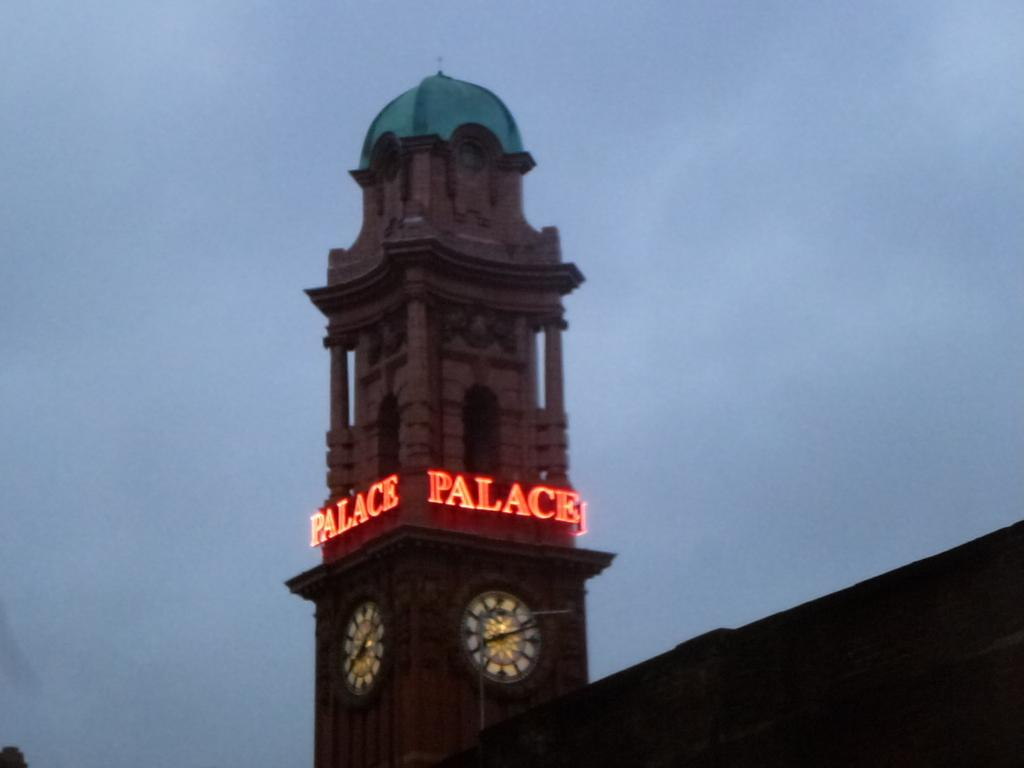<image>
Create a compact narrative representing the image presented. The clock tower has a sign with lights called Palace 